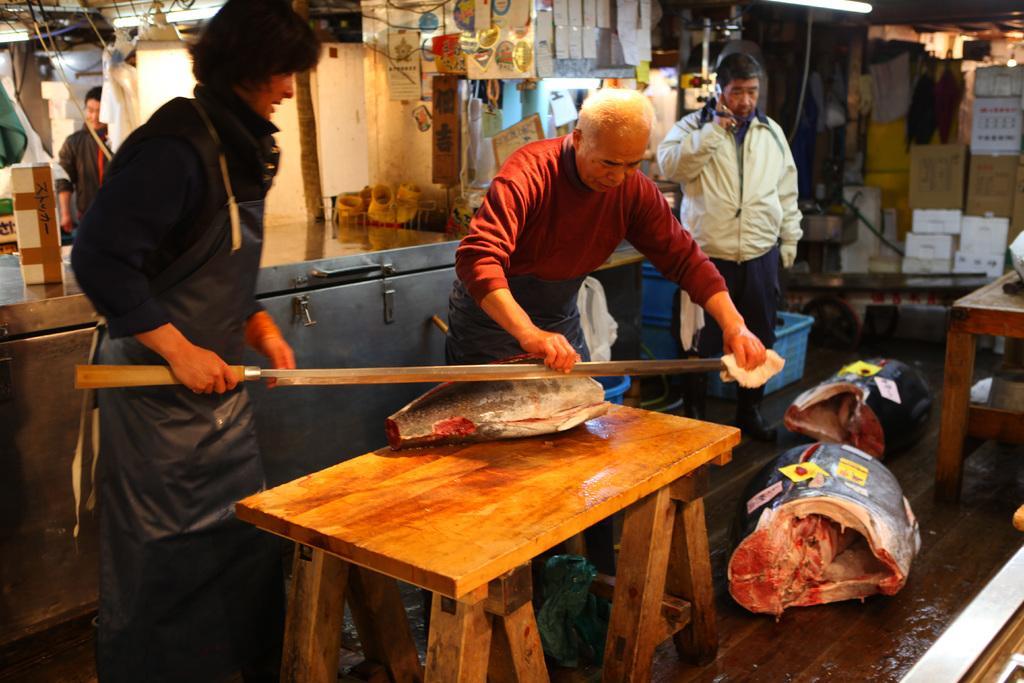Could you give a brief overview of what you see in this image? This picture is of inside there are two persons standing and trying to cut the flesh placed on the top of the table. There is a Man standing and talking on mobile phone. In the background we can see the papers hanging and some boxes. There is a table and a person seems to be standing. 